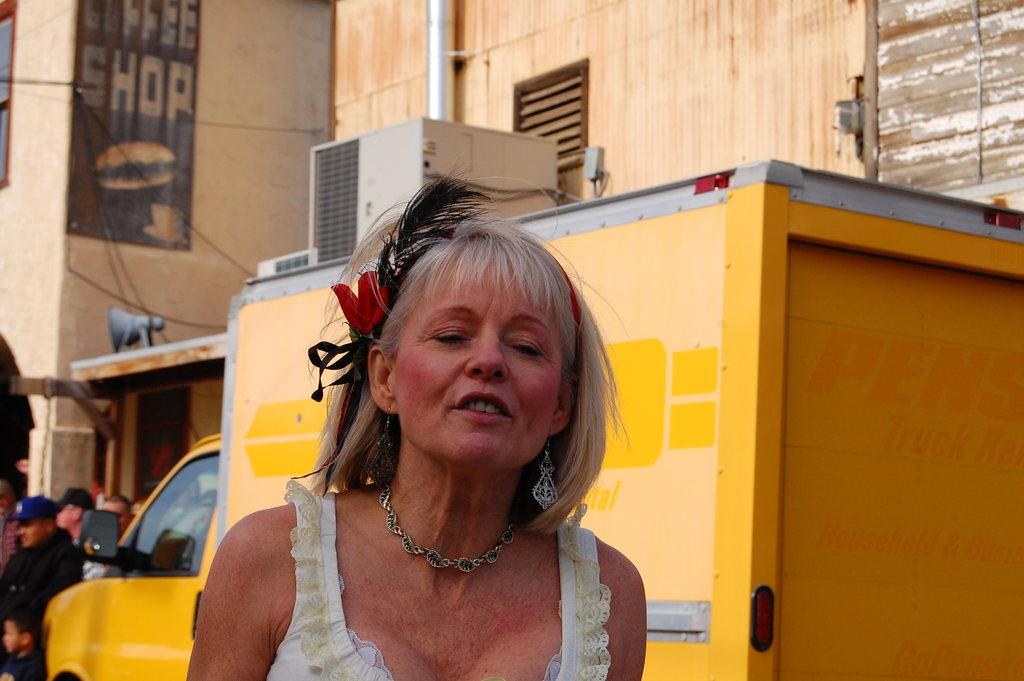What kind of diner is behind the woman?
Offer a very short reply. Coffee shop. 